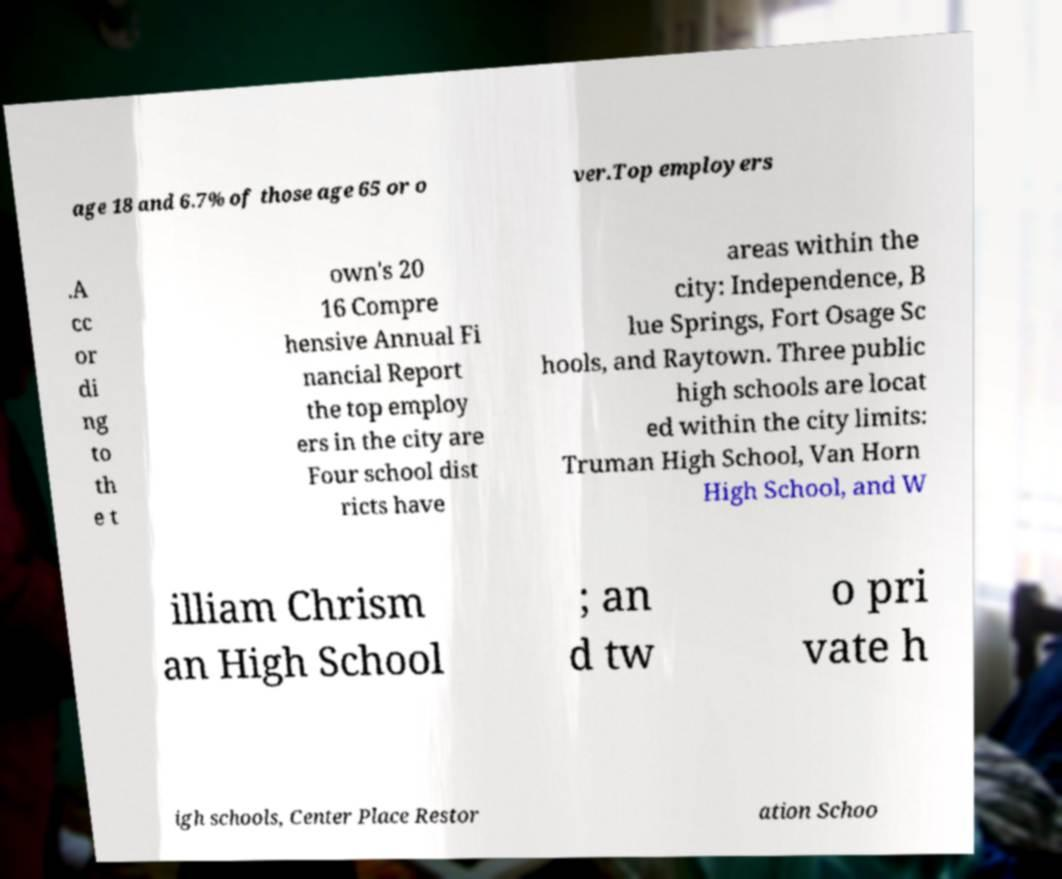Can you accurately transcribe the text from the provided image for me? age 18 and 6.7% of those age 65 or o ver.Top employers .A cc or di ng to th e t own's 20 16 Compre hensive Annual Fi nancial Report the top employ ers in the city are Four school dist ricts have areas within the city: Independence, B lue Springs, Fort Osage Sc hools, and Raytown. Three public high schools are locat ed within the city limits: Truman High School, Van Horn High School, and W illiam Chrism an High School ; an d tw o pri vate h igh schools, Center Place Restor ation Schoo 